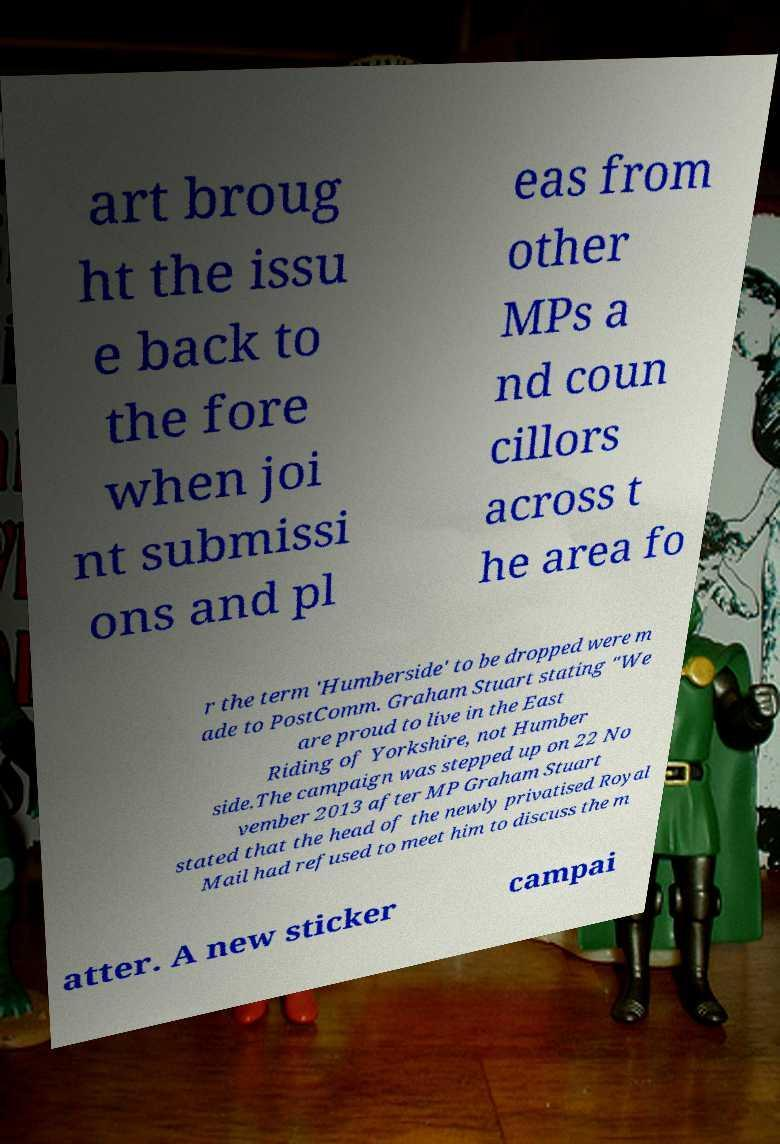Please read and relay the text visible in this image. What does it say? art broug ht the issu e back to the fore when joi nt submissi ons and pl eas from other MPs a nd coun cillors across t he area fo r the term 'Humberside' to be dropped were m ade to PostComm. Graham Stuart stating "We are proud to live in the East Riding of Yorkshire, not Humber side.The campaign was stepped up on 22 No vember 2013 after MP Graham Stuart stated that the head of the newly privatised Royal Mail had refused to meet him to discuss the m atter. A new sticker campai 